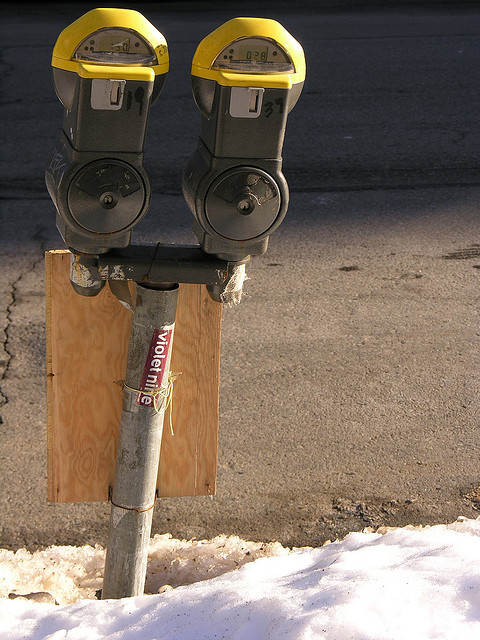Identify the text displayed in this image. VIOLET nine 37 